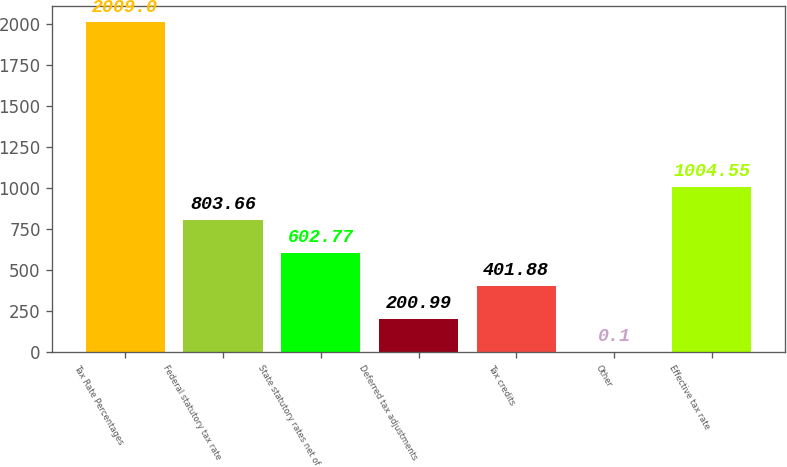Convert chart to OTSL. <chart><loc_0><loc_0><loc_500><loc_500><bar_chart><fcel>Tax Rate Percentages<fcel>Federal statutory tax rate<fcel>State statutory rates net of<fcel>Deferred tax adjustments<fcel>Tax credits<fcel>Other<fcel>Effective tax rate<nl><fcel>2009<fcel>803.66<fcel>602.77<fcel>200.99<fcel>401.88<fcel>0.1<fcel>1004.55<nl></chart> 